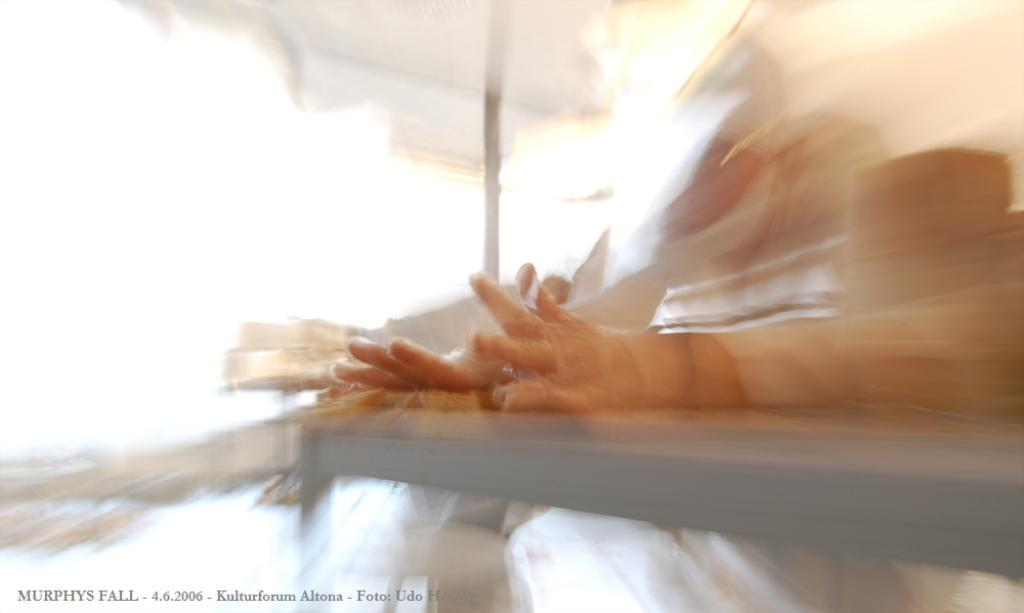Who or what is in the image? There is a person visible in the image. Where is the person located in relation to other objects in the image? The person is in front of a table. What is the position of the table in the image? The table is in the middle of the image. What other structure can be seen in the image? There is a tent in the image. What else can be seen in the image besides the person, table, and tent? Text is visible in the image. Can we determine the time of day when the image was taken? The image might have been taken during the day, but we cannot be certain. How many balls are visible on the hill in the image? There is no hill or balls present in the image. 